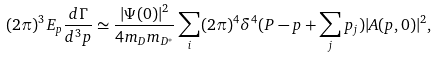<formula> <loc_0><loc_0><loc_500><loc_500>( 2 \pi ) ^ { 3 } E _ { p } \frac { d \Gamma } { d ^ { 3 } p } \simeq \frac { | \Psi ( { 0 } ) | ^ { 2 } } { 4 m _ { D } m _ { D ^ { * } } } \sum _ { i } ( 2 \pi ) ^ { 4 } \delta ^ { 4 } ( P - p + \sum _ { j } p _ { j } ) | A ( { p } , { 0 } ) | ^ { 2 } ,</formula> 